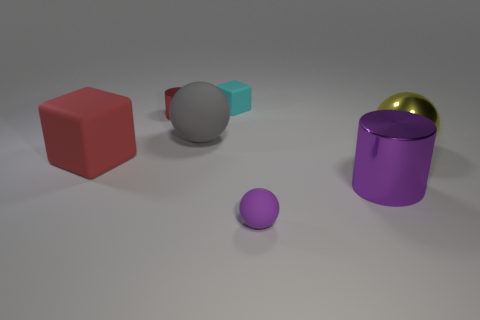Subtract all large spheres. How many spheres are left? 1 Add 2 tiny purple spheres. How many objects exist? 9 Subtract all gray spheres. How many spheres are left? 2 Subtract 2 cylinders. How many cylinders are left? 0 Subtract all cylinders. How many objects are left? 5 Add 1 tiny cyan blocks. How many tiny cyan blocks are left? 2 Add 5 small brown spheres. How many small brown spheres exist? 5 Subtract 0 cyan cylinders. How many objects are left? 7 Subtract all red balls. Subtract all yellow cylinders. How many balls are left? 3 Subtract all green cylinders. How many purple spheres are left? 1 